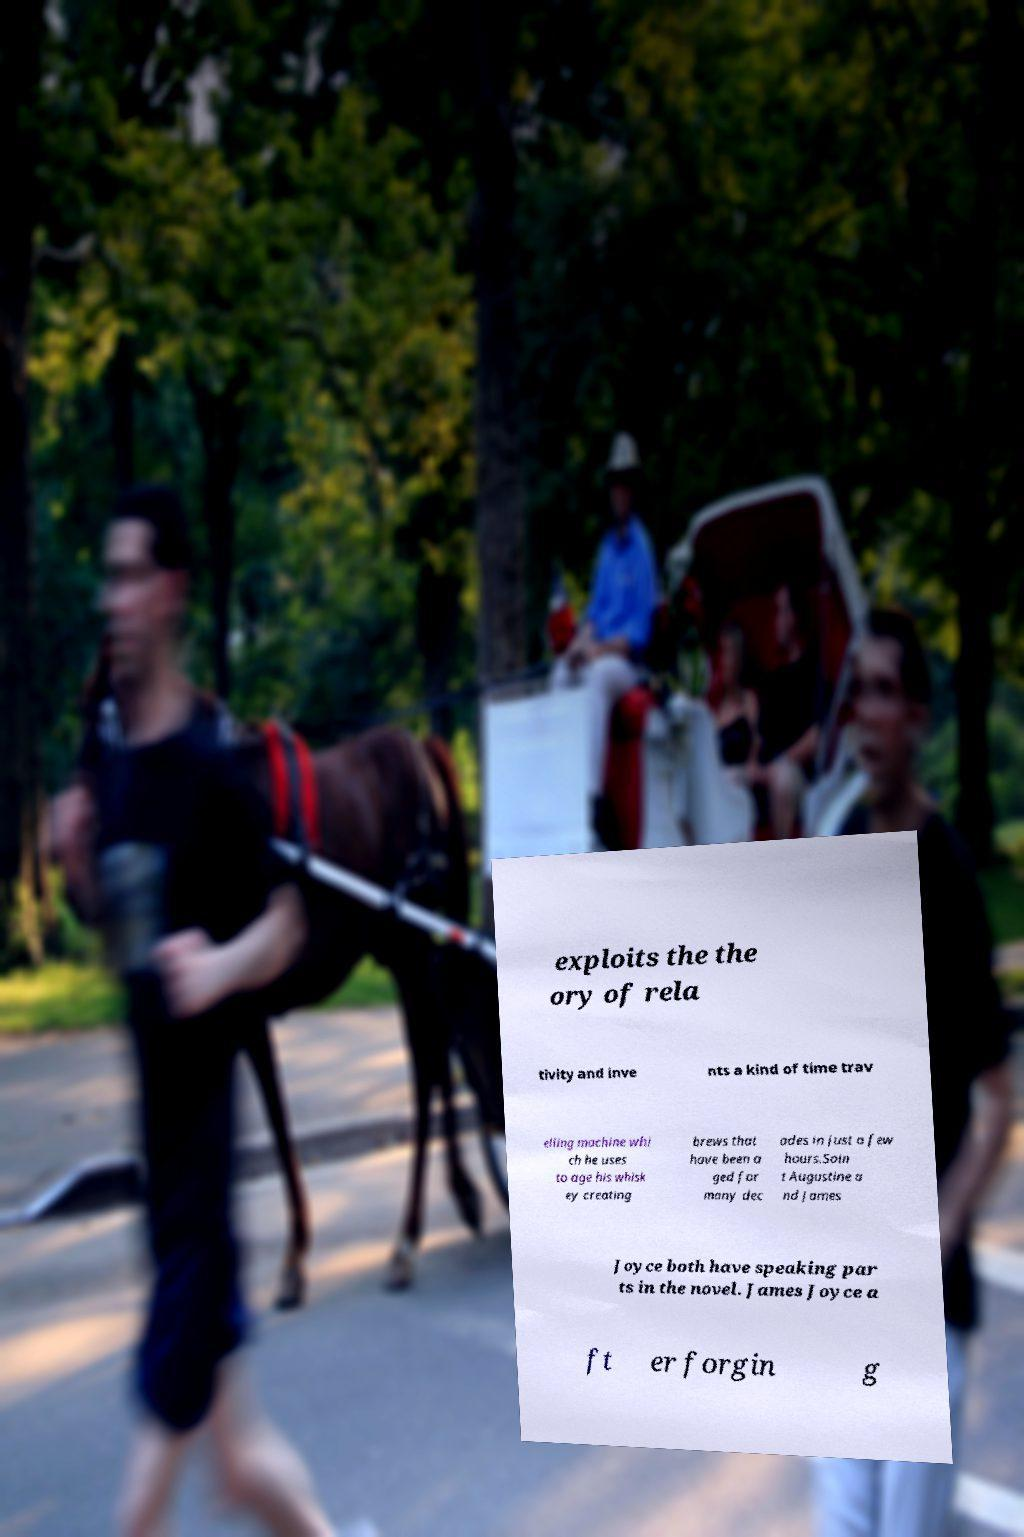Could you extract and type out the text from this image? exploits the the ory of rela tivity and inve nts a kind of time trav elling machine whi ch he uses to age his whisk ey creating brews that have been a ged for many dec ades in just a few hours.Sain t Augustine a nd James Joyce both have speaking par ts in the novel. James Joyce a ft er forgin g 